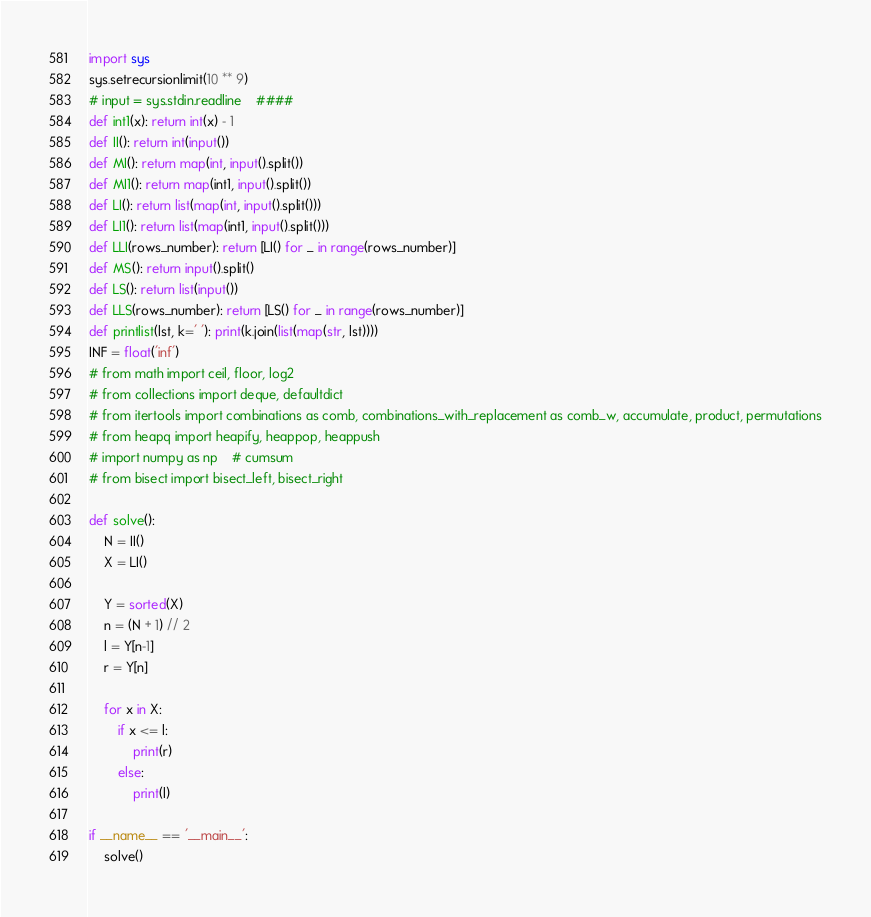Convert code to text. <code><loc_0><loc_0><loc_500><loc_500><_Python_>import sys
sys.setrecursionlimit(10 ** 9)
# input = sys.stdin.readline    ####
def int1(x): return int(x) - 1
def II(): return int(input())
def MI(): return map(int, input().split())
def MI1(): return map(int1, input().split())
def LI(): return list(map(int, input().split()))
def LI1(): return list(map(int1, input().split()))
def LLI(rows_number): return [LI() for _ in range(rows_number)]
def MS(): return input().split()
def LS(): return list(input())
def LLS(rows_number): return [LS() for _ in range(rows_number)]
def printlist(lst, k=' '): print(k.join(list(map(str, lst))))
INF = float('inf')
# from math import ceil, floor, log2
# from collections import deque, defaultdict
# from itertools import combinations as comb, combinations_with_replacement as comb_w, accumulate, product, permutations
# from heapq import heapify, heappop, heappush
# import numpy as np    # cumsum
# from bisect import bisect_left, bisect_right

def solve():
    N = II()
    X = LI()

    Y = sorted(X)
    n = (N + 1) // 2
    l = Y[n-1]
    r = Y[n]

    for x in X:
        if x <= l:
            print(r)
        else:
            print(l)

if __name__ == '__main__':
    solve()

</code> 